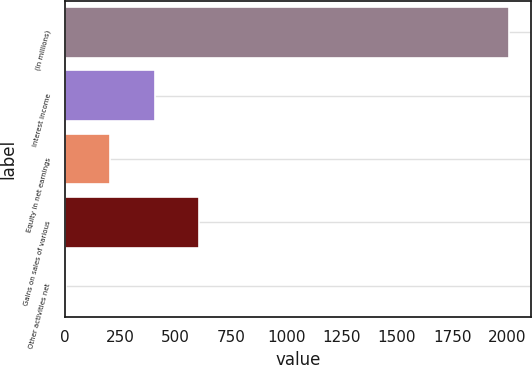Convert chart. <chart><loc_0><loc_0><loc_500><loc_500><bar_chart><fcel>(In millions)<fcel>Interest income<fcel>Equity in net earnings<fcel>Gains on sales of various<fcel>Other activities net<nl><fcel>2005<fcel>405<fcel>205<fcel>605<fcel>5<nl></chart> 